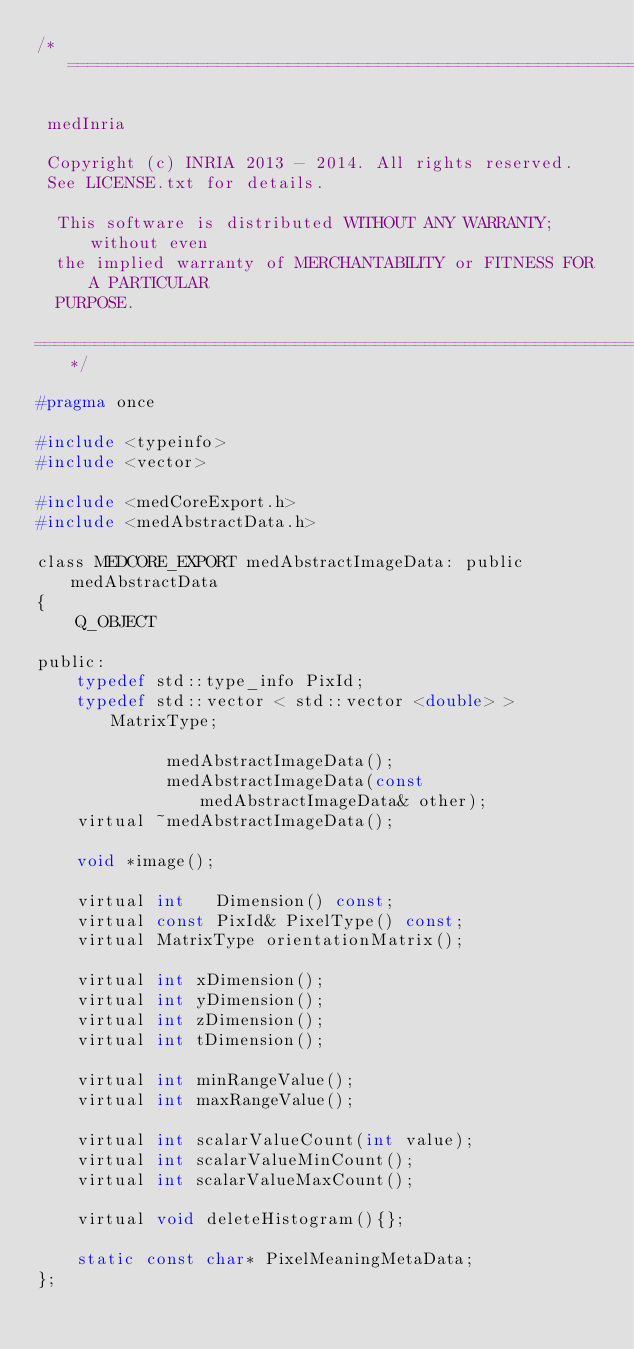<code> <loc_0><loc_0><loc_500><loc_500><_C_>/*=========================================================================

 medInria

 Copyright (c) INRIA 2013 - 2014. All rights reserved.
 See LICENSE.txt for details.
 
  This software is distributed WITHOUT ANY WARRANTY; without even
  the implied warranty of MERCHANTABILITY or FITNESS FOR A PARTICULAR
  PURPOSE.

=========================================================================*/

#pragma once

#include <typeinfo>
#include <vector>

#include <medCoreExport.h>
#include <medAbstractData.h>

class MEDCORE_EXPORT medAbstractImageData: public medAbstractData
{
    Q_OBJECT

public:
    typedef std::type_info PixId;
    typedef std::vector < std::vector <double> > MatrixType;

             medAbstractImageData();
             medAbstractImageData(const medAbstractImageData& other);
    virtual ~medAbstractImageData();

    void *image();

    virtual int   Dimension() const;
    virtual const PixId& PixelType() const;
    virtual MatrixType orientationMatrix();

    virtual int xDimension();
    virtual int yDimension();
    virtual int zDimension();
    virtual int tDimension();

    virtual int minRangeValue();
    virtual int maxRangeValue();

    virtual int scalarValueCount(int value);
    virtual int scalarValueMinCount();
    virtual int scalarValueMaxCount();

    virtual void deleteHistogram(){};

    static const char* PixelMeaningMetaData;
};
</code> 